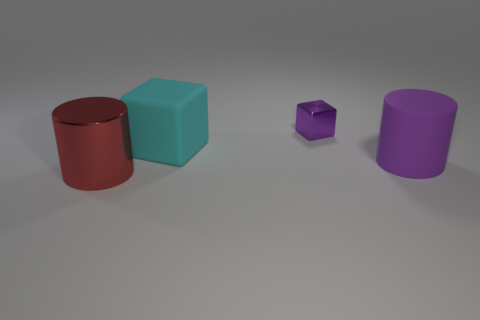Is there anything else that has the same size as the metallic cylinder?
Keep it short and to the point. Yes. What material is the cylinder on the right side of the big cylinder that is on the left side of the tiny purple block?
Provide a succinct answer. Rubber. Are there an equal number of big things left of the rubber cylinder and big shiny cylinders on the right side of the large metal object?
Offer a terse response. No. What number of things are either objects left of the tiny metallic cube or large cylinders that are on the right side of the tiny purple thing?
Your answer should be very brief. 3. What is the material of the thing that is right of the big cube and in front of the cyan cube?
Provide a short and direct response. Rubber. How big is the cylinder left of the purple object that is to the left of the cylinder right of the big red metallic object?
Give a very brief answer. Large. Is the number of red shiny cylinders greater than the number of small brown rubber things?
Give a very brief answer. Yes. Are the large thing that is behind the large purple rubber cylinder and the tiny purple thing made of the same material?
Your response must be concise. No. Are there fewer brown spheres than small metallic objects?
Keep it short and to the point. Yes. There is a cylinder behind the large cylinder that is to the left of the tiny purple thing; is there a big purple cylinder that is behind it?
Keep it short and to the point. No. 